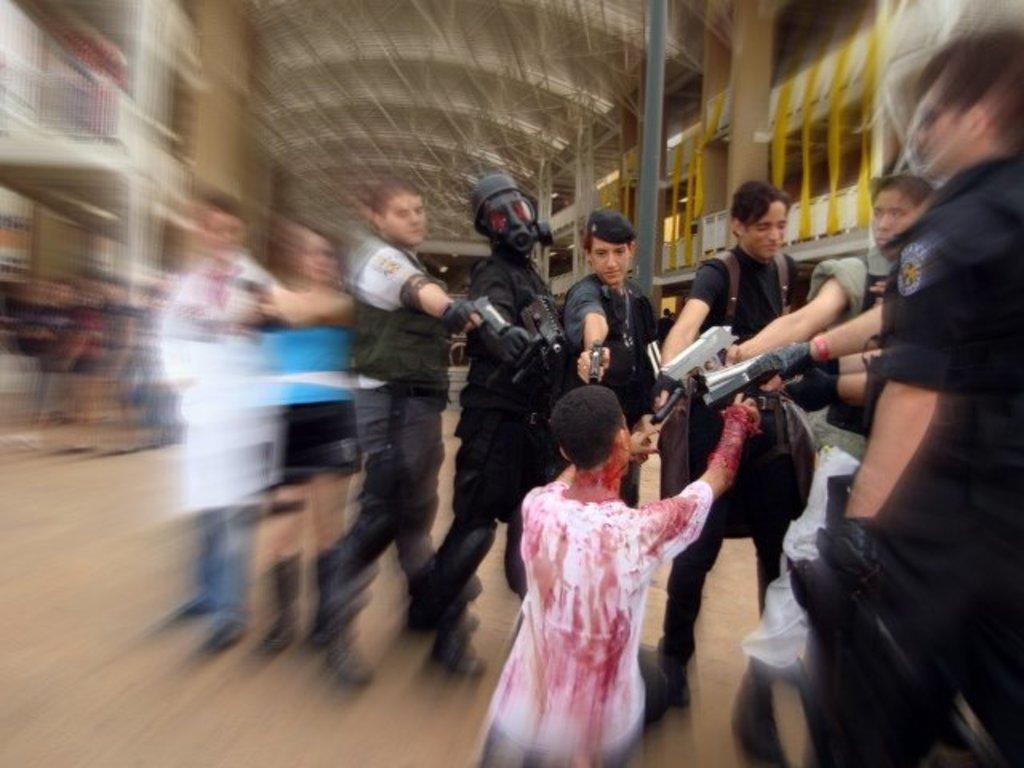Please provide a concise description of this image. In this image we can see persons standing on the floor and holding guns in their hands. In the background there are buildings. 